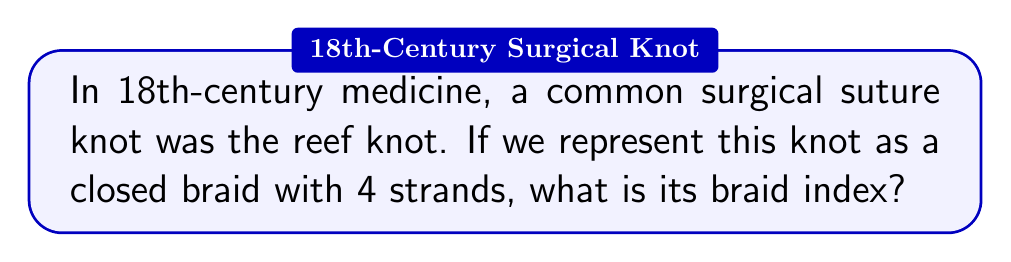Teach me how to tackle this problem. To determine the braid index of the reef knot used in 18th-century surgical sutures, we'll follow these steps:

1. Understand the reef knot structure:
   The reef knot is formed by tying two overhand knots, one left-handed and one right-handed.

2. Represent the reef knot as a closed braid:
   We can represent the reef knot using 4 strands in a braid diagram.

3. Analyze the braid representation:
   The reef knot can be represented by the braid word $\sigma_1\sigma_3\sigma_2^{-1}\sigma_1^{-1}\sigma_3^{-1}\sigma_2$, where $\sigma_i$ represents a positive crossing of strand $i$ over strand $i+1$, and $\sigma_i^{-1}$ represents the inverse.

4. Define braid index:
   The braid index is the minimum number of strands needed to represent a knot as a closed braid.

5. Determine the minimum number of strands:
   For the reef knot, we need at least 4 strands to accurately represent its structure without introducing additional complexity.

6. Verify no simpler representation exists:
   It's not possible to represent the reef knot with fewer than 4 strands without changing its topological structure.

Therefore, the braid index of the reef knot, as used in 18th-century surgical sutures, is 4.
Answer: 4 